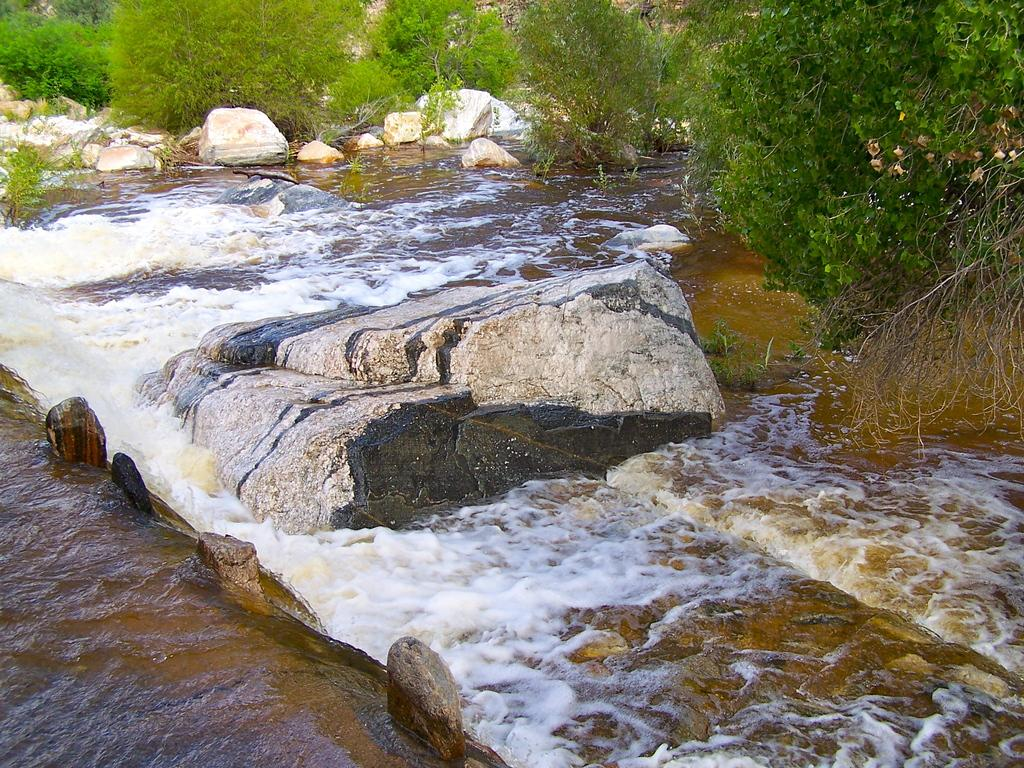What is the primary element visible in the image? There is water in the image. What other objects can be seen in the image? There are stones in the image. What can be seen in the background of the image? There are trees in the background of the image. What type of coil is present in the water in the image? There is no coil present in the water in the image. What time of day is it in the image, considering the presence of oatmeal? There is no oatmeal present in the image, so it is not possible to determine the time of day based on that information. 